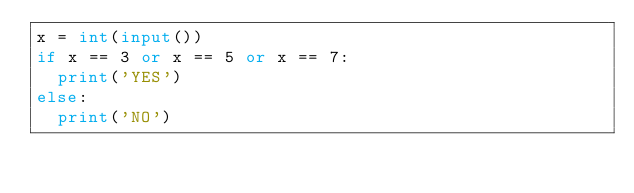<code> <loc_0><loc_0><loc_500><loc_500><_Python_>x = int(input())
if x == 3 or x == 5 or x == 7:
  print('YES')
else:
  print('NO')</code> 